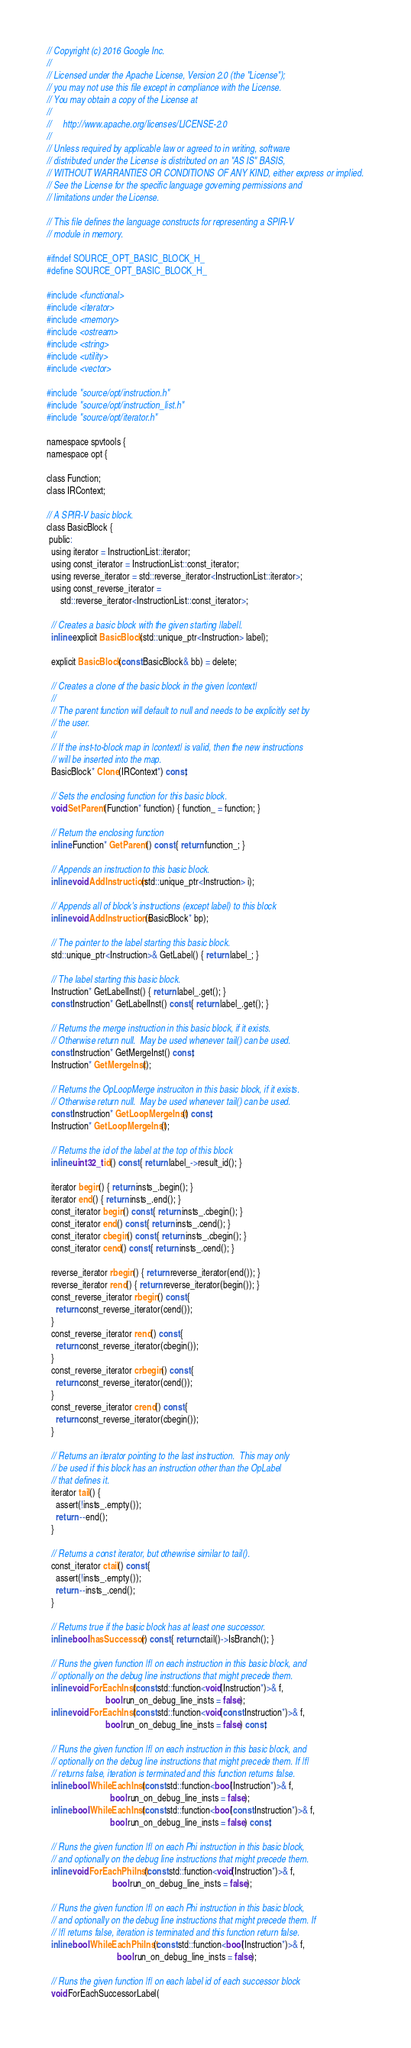Convert code to text. <code><loc_0><loc_0><loc_500><loc_500><_C_>// Copyright (c) 2016 Google Inc.
//
// Licensed under the Apache License, Version 2.0 (the "License");
// you may not use this file except in compliance with the License.
// You may obtain a copy of the License at
//
//     http://www.apache.org/licenses/LICENSE-2.0
//
// Unless required by applicable law or agreed to in writing, software
// distributed under the License is distributed on an "AS IS" BASIS,
// WITHOUT WARRANTIES OR CONDITIONS OF ANY KIND, either express or implied.
// See the License for the specific language governing permissions and
// limitations under the License.

// This file defines the language constructs for representing a SPIR-V
// module in memory.

#ifndef SOURCE_OPT_BASIC_BLOCK_H_
#define SOURCE_OPT_BASIC_BLOCK_H_

#include <functional>
#include <iterator>
#include <memory>
#include <ostream>
#include <string>
#include <utility>
#include <vector>

#include "source/opt/instruction.h"
#include "source/opt/instruction_list.h"
#include "source/opt/iterator.h"

namespace spvtools {
namespace opt {

class Function;
class IRContext;

// A SPIR-V basic block.
class BasicBlock {
 public:
  using iterator = InstructionList::iterator;
  using const_iterator = InstructionList::const_iterator;
  using reverse_iterator = std::reverse_iterator<InstructionList::iterator>;
  using const_reverse_iterator =
      std::reverse_iterator<InstructionList::const_iterator>;

  // Creates a basic block with the given starting |label|.
  inline explicit BasicBlock(std::unique_ptr<Instruction> label);

  explicit BasicBlock(const BasicBlock& bb) = delete;

  // Creates a clone of the basic block in the given |context|
  //
  // The parent function will default to null and needs to be explicitly set by
  // the user.
  //
  // If the inst-to-block map in |context| is valid, then the new instructions
  // will be inserted into the map.
  BasicBlock* Clone(IRContext*) const;

  // Sets the enclosing function for this basic block.
  void SetParent(Function* function) { function_ = function; }

  // Return the enclosing function
  inline Function* GetParent() const { return function_; }

  // Appends an instruction to this basic block.
  inline void AddInstruction(std::unique_ptr<Instruction> i);

  // Appends all of block's instructions (except label) to this block
  inline void AddInstructions(BasicBlock* bp);

  // The pointer to the label starting this basic block.
  std::unique_ptr<Instruction>& GetLabel() { return label_; }

  // The label starting this basic block.
  Instruction* GetLabelInst() { return label_.get(); }
  const Instruction* GetLabelInst() const { return label_.get(); }

  // Returns the merge instruction in this basic block, if it exists.
  // Otherwise return null.  May be used whenever tail() can be used.
  const Instruction* GetMergeInst() const;
  Instruction* GetMergeInst();

  // Returns the OpLoopMerge instruciton in this basic block, if it exists.
  // Otherwise return null.  May be used whenever tail() can be used.
  const Instruction* GetLoopMergeInst() const;
  Instruction* GetLoopMergeInst();

  // Returns the id of the label at the top of this block
  inline uint32_t id() const { return label_->result_id(); }

  iterator begin() { return insts_.begin(); }
  iterator end() { return insts_.end(); }
  const_iterator begin() const { return insts_.cbegin(); }
  const_iterator end() const { return insts_.cend(); }
  const_iterator cbegin() const { return insts_.cbegin(); }
  const_iterator cend() const { return insts_.cend(); }

  reverse_iterator rbegin() { return reverse_iterator(end()); }
  reverse_iterator rend() { return reverse_iterator(begin()); }
  const_reverse_iterator rbegin() const {
    return const_reverse_iterator(cend());
  }
  const_reverse_iterator rend() const {
    return const_reverse_iterator(cbegin());
  }
  const_reverse_iterator crbegin() const {
    return const_reverse_iterator(cend());
  }
  const_reverse_iterator crend() const {
    return const_reverse_iterator(cbegin());
  }

  // Returns an iterator pointing to the last instruction.  This may only
  // be used if this block has an instruction other than the OpLabel
  // that defines it.
  iterator tail() {
    assert(!insts_.empty());
    return --end();
  }

  // Returns a const iterator, but othewrise similar to tail().
  const_iterator ctail() const {
    assert(!insts_.empty());
    return --insts_.cend();
  }

  // Returns true if the basic block has at least one successor.
  inline bool hasSuccessor() const { return ctail()->IsBranch(); }

  // Runs the given function |f| on each instruction in this basic block, and
  // optionally on the debug line instructions that might precede them.
  inline void ForEachInst(const std::function<void(Instruction*)>& f,
                          bool run_on_debug_line_insts = false);
  inline void ForEachInst(const std::function<void(const Instruction*)>& f,
                          bool run_on_debug_line_insts = false) const;

  // Runs the given function |f| on each instruction in this basic block, and
  // optionally on the debug line instructions that might precede them. If |f|
  // returns false, iteration is terminated and this function returns false.
  inline bool WhileEachInst(const std::function<bool(Instruction*)>& f,
                            bool run_on_debug_line_insts = false);
  inline bool WhileEachInst(const std::function<bool(const Instruction*)>& f,
                            bool run_on_debug_line_insts = false) const;

  // Runs the given function |f| on each Phi instruction in this basic block,
  // and optionally on the debug line instructions that might precede them.
  inline void ForEachPhiInst(const std::function<void(Instruction*)>& f,
                             bool run_on_debug_line_insts = false);

  // Runs the given function |f| on each Phi instruction in this basic block,
  // and optionally on the debug line instructions that might precede them. If
  // |f| returns false, iteration is terminated and this function return false.
  inline bool WhileEachPhiInst(const std::function<bool(Instruction*)>& f,
                               bool run_on_debug_line_insts = false);

  // Runs the given function |f| on each label id of each successor block
  void ForEachSuccessorLabel(</code> 